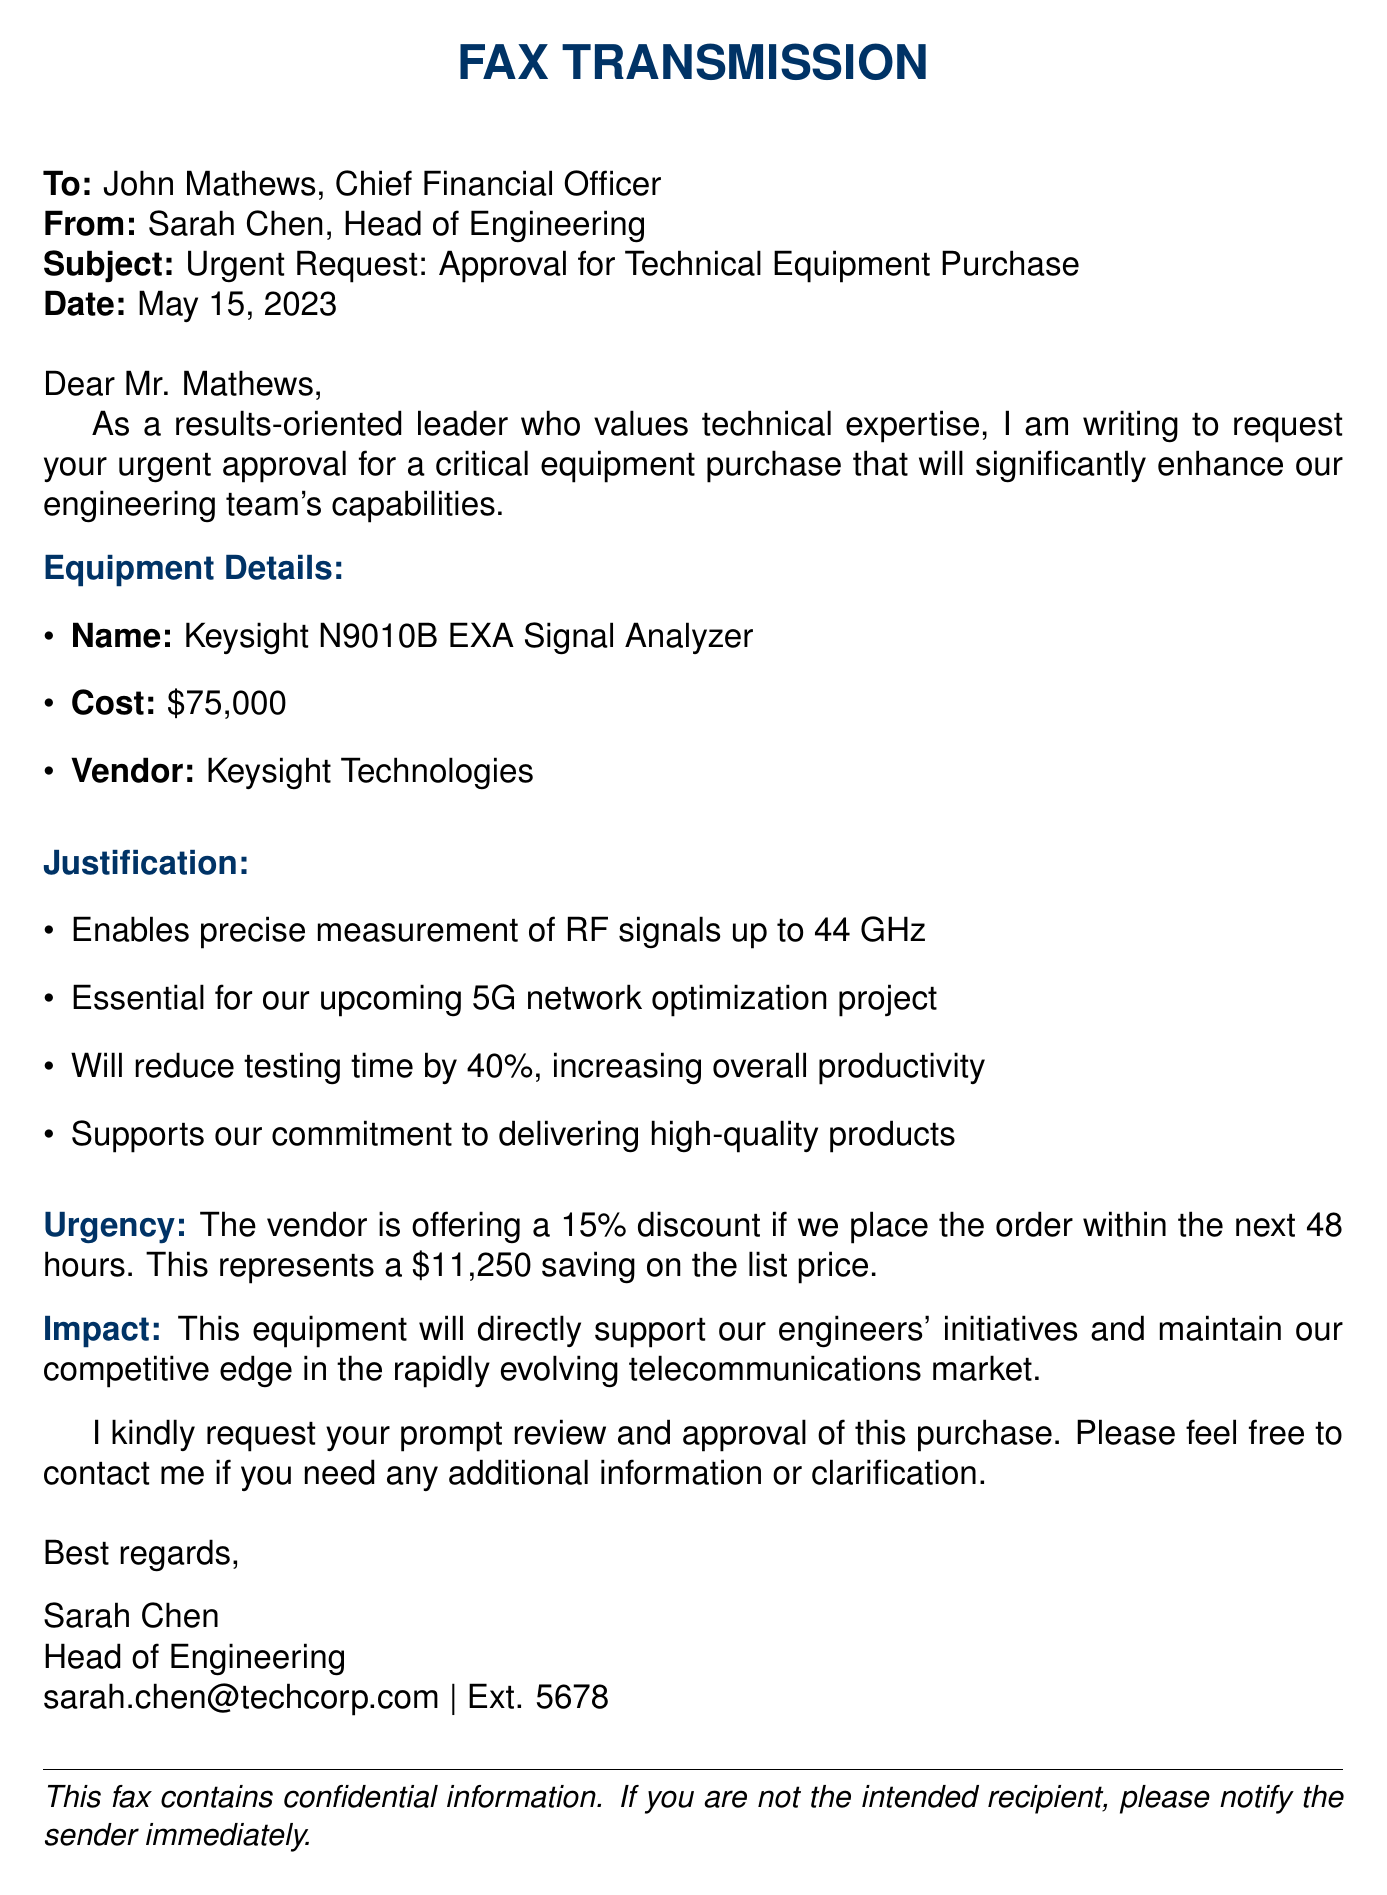What is the name of the equipment being requested? The name of the equipment is specified in the document.
Answer: Keysight N9010B EXA Signal Analyzer What is the cost of the equipment? The document clearly lists the cost associated with the equipment request.
Answer: $75,000 Who is the vendor for the equipment? The vendor's name is provided in the equipment details section of the document.
Answer: Keysight Technologies What is the offered discount if the order is placed within 48 hours? The document mentions the discount percentage available if the order is made in the specified timeframe.
Answer: 15% What is the expected reduction in testing time with the new equipment? The expected reduction in testing time is outlined in the justification section of the document.
Answer: 40% What project is the equipment essential for? The document explicitly states the project that requires the equipment for optimal functioning.
Answer: 5G network optimization project What will this equipment directly support? The document indicates what the new equipment will support or enhance.
Answer: Engineers' initiatives What is the date of the fax? The date of the fax can be found at the beginning of the document.
Answer: May 15, 2023 